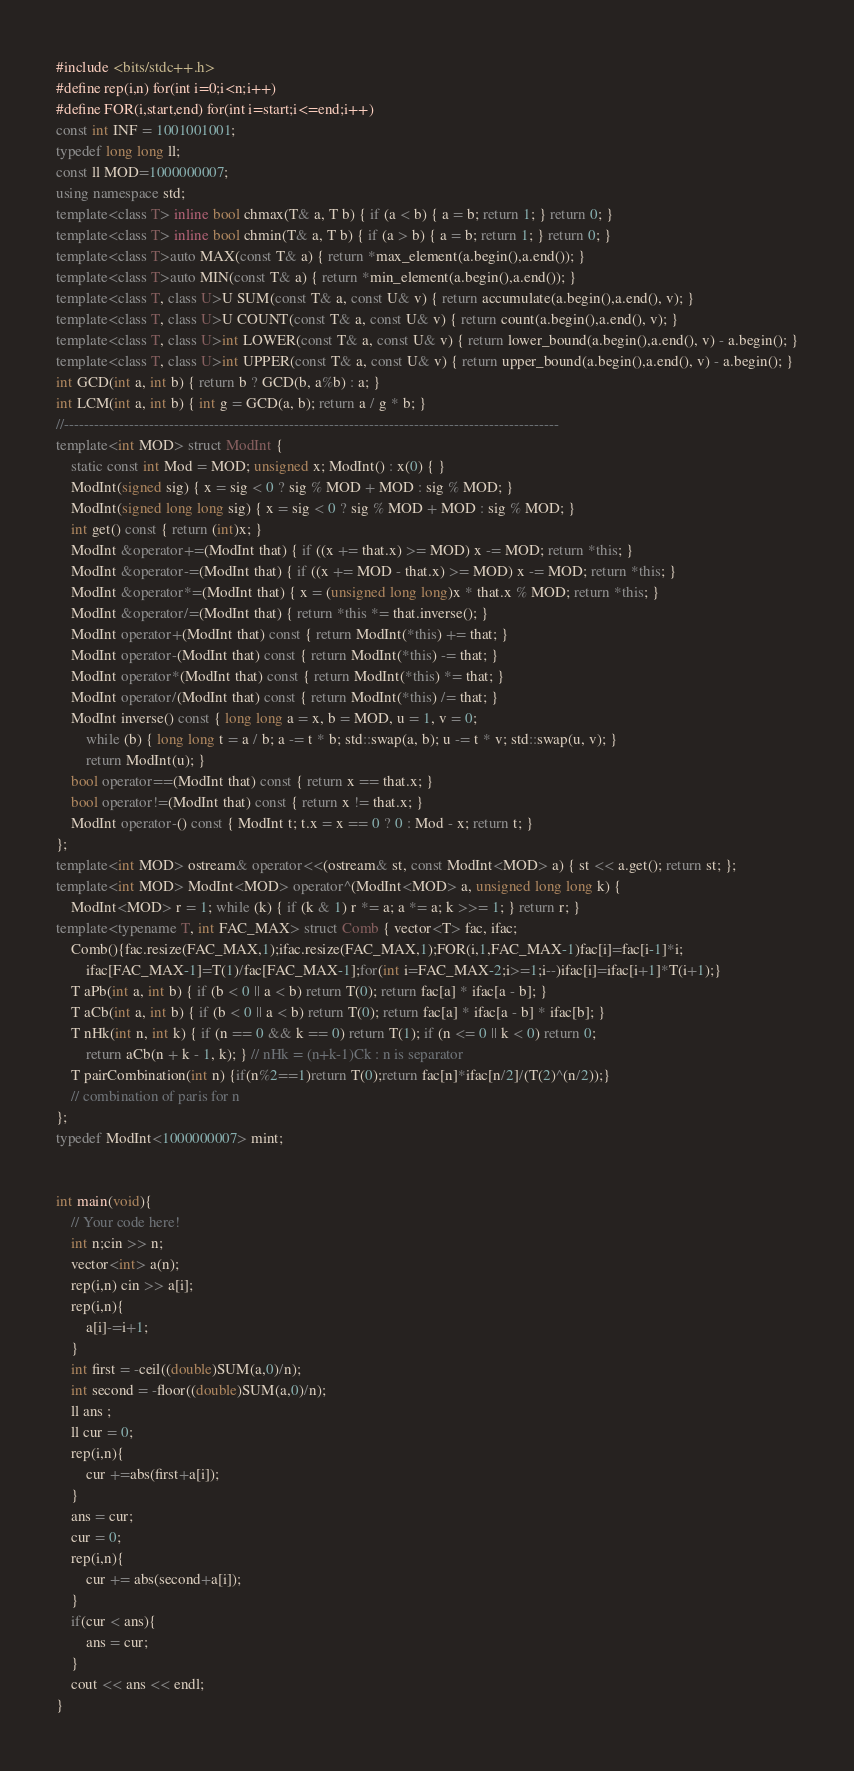<code> <loc_0><loc_0><loc_500><loc_500><_C++_>#include <bits/stdc++.h>
#define rep(i,n) for(int i=0;i<n;i++)
#define FOR(i,start,end) for(int i=start;i<=end;i++)
const int INF = 1001001001;
typedef long long ll;
const ll MOD=1000000007;
using namespace std;
template<class T> inline bool chmax(T& a, T b) { if (a < b) { a = b; return 1; } return 0; }
template<class T> inline bool chmin(T& a, T b) { if (a > b) { a = b; return 1; } return 0; }
template<class T>auto MAX(const T& a) { return *max_element(a.begin(),a.end()); }
template<class T>auto MIN(const T& a) { return *min_element(a.begin(),a.end()); }
template<class T, class U>U SUM(const T& a, const U& v) { return accumulate(a.begin(),a.end(), v); }
template<class T, class U>U COUNT(const T& a, const U& v) { return count(a.begin(),a.end(), v); }
template<class T, class U>int LOWER(const T& a, const U& v) { return lower_bound(a.begin(),a.end(), v) - a.begin(); }
template<class T, class U>int UPPER(const T& a, const U& v) { return upper_bound(a.begin(),a.end(), v) - a.begin(); }
int GCD(int a, int b) { return b ? GCD(b, a%b) : a; }
int LCM(int a, int b) { int g = GCD(a, b); return a / g * b; }
//---------------------------------------------------------------------------------------------------
template<int MOD> struct ModInt {
    static const int Mod = MOD; unsigned x; ModInt() : x(0) { }
    ModInt(signed sig) { x = sig < 0 ? sig % MOD + MOD : sig % MOD; }
    ModInt(signed long long sig) { x = sig < 0 ? sig % MOD + MOD : sig % MOD; }
    int get() const { return (int)x; }
    ModInt &operator+=(ModInt that) { if ((x += that.x) >= MOD) x -= MOD; return *this; }
    ModInt &operator-=(ModInt that) { if ((x += MOD - that.x) >= MOD) x -= MOD; return *this; }
    ModInt &operator*=(ModInt that) { x = (unsigned long long)x * that.x % MOD; return *this; }
    ModInt &operator/=(ModInt that) { return *this *= that.inverse(); }
    ModInt operator+(ModInt that) const { return ModInt(*this) += that; }
    ModInt operator-(ModInt that) const { return ModInt(*this) -= that; }
    ModInt operator*(ModInt that) const { return ModInt(*this) *= that; }
    ModInt operator/(ModInt that) const { return ModInt(*this) /= that; }
    ModInt inverse() const { long long a = x, b = MOD, u = 1, v = 0;
        while (b) { long long t = a / b; a -= t * b; std::swap(a, b); u -= t * v; std::swap(u, v); }
        return ModInt(u); }
    bool operator==(ModInt that) const { return x == that.x; }
    bool operator!=(ModInt that) const { return x != that.x; }
    ModInt operator-() const { ModInt t; t.x = x == 0 ? 0 : Mod - x; return t; }
};
template<int MOD> ostream& operator<<(ostream& st, const ModInt<MOD> a) { st << a.get(); return st; };
template<int MOD> ModInt<MOD> operator^(ModInt<MOD> a, unsigned long long k) {
    ModInt<MOD> r = 1; while (k) { if (k & 1) r *= a; a *= a; k >>= 1; } return r; }
template<typename T, int FAC_MAX> struct Comb { vector<T> fac, ifac;
    Comb(){fac.resize(FAC_MAX,1);ifac.resize(FAC_MAX,1);FOR(i,1,FAC_MAX-1)fac[i]=fac[i-1]*i;
        ifac[FAC_MAX-1]=T(1)/fac[FAC_MAX-1];for(int i=FAC_MAX-2;i>=1;i--)ifac[i]=ifac[i+1]*T(i+1);}
    T aPb(int a, int b) { if (b < 0 || a < b) return T(0); return fac[a] * ifac[a - b]; }
    T aCb(int a, int b) { if (b < 0 || a < b) return T(0); return fac[a] * ifac[a - b] * ifac[b]; }
    T nHk(int n, int k) { if (n == 0 && k == 0) return T(1); if (n <= 0 || k < 0) return 0;
        return aCb(n + k - 1, k); } // nHk = (n+k-1)Ck : n is separator
    T pairCombination(int n) {if(n%2==1)return T(0);return fac[n]*ifac[n/2]/(T(2)^(n/2));}
    // combination of paris for n
}; 
typedef ModInt<1000000007> mint;


int main(void){
    // Your code here!
    int n;cin >> n;
    vector<int> a(n);
    rep(i,n) cin >> a[i];
    rep(i,n){
        a[i]-=i+1;
    }
    int first = -ceil((double)SUM(a,0)/n);
    int second = -floor((double)SUM(a,0)/n);
    ll ans ;
    ll cur = 0;
    rep(i,n){
        cur +=abs(first+a[i]);
    }
    ans = cur;
    cur = 0;
    rep(i,n){
        cur += abs(second+a[i]);
    }
    if(cur < ans){
        ans = cur;
    }
    cout << ans << endl;
}
</code> 